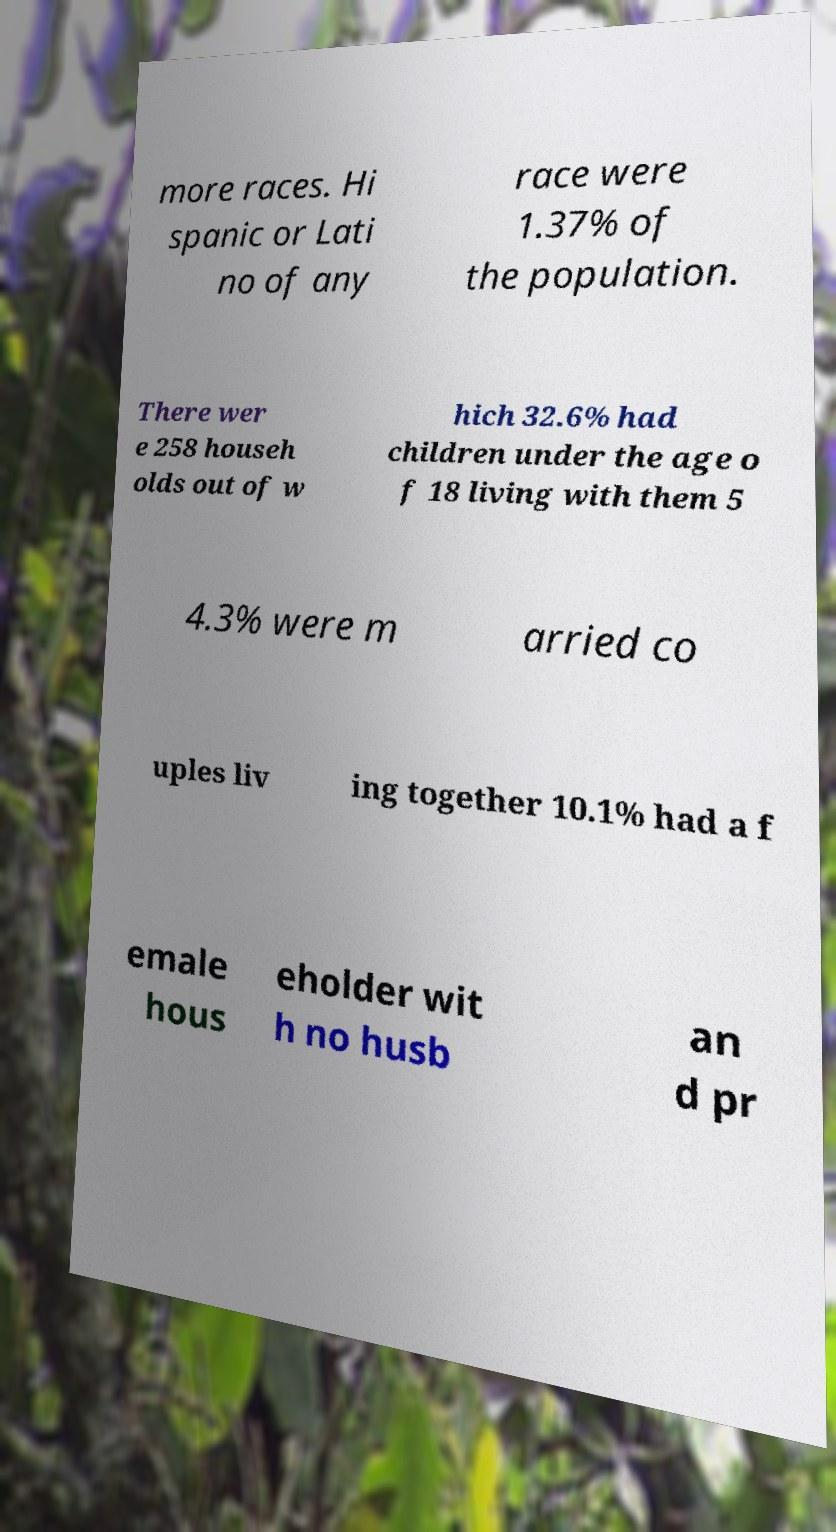For documentation purposes, I need the text within this image transcribed. Could you provide that? more races. Hi spanic or Lati no of any race were 1.37% of the population. There wer e 258 househ olds out of w hich 32.6% had children under the age o f 18 living with them 5 4.3% were m arried co uples liv ing together 10.1% had a f emale hous eholder wit h no husb an d pr 